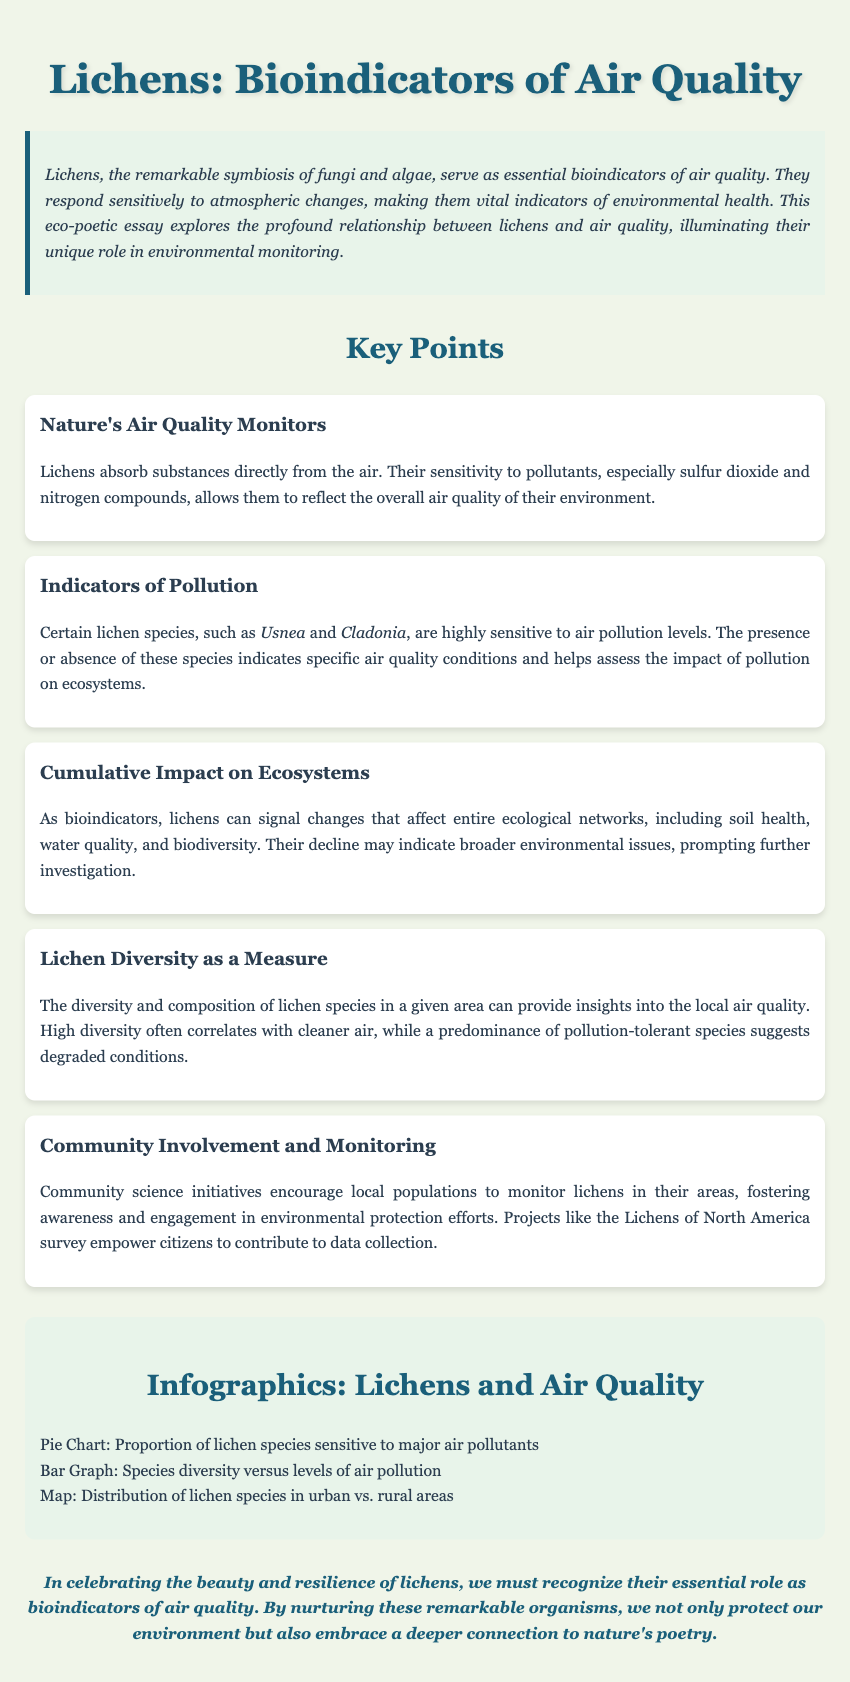What is the title of the essay? The title of the essay is explicitly mentioned in the document header.
Answer: Lichens: Bioindicators of Air Quality What type of organisms are lichens described as? The document describes lichens as a remarkable symbiosis of fungi and algae.
Answer: Symbiosis of fungi and algae Which species is mentioned as sensitive to air pollution? Specific lichen species that indicate pollution levels are detailed in one of the key points.
Answer: Usnea and Cladonia What does high lichen diversity correlate with? The relationship between lichen diversity and air quality is articulated in the key point regarding lichen diversity.
Answer: Cleaner air What community initiative is highlighted in the document? The document mentions a specific project aimed at encouraging local populations to engage in monitoring lichens.
Answer: Lichens of North America survey 